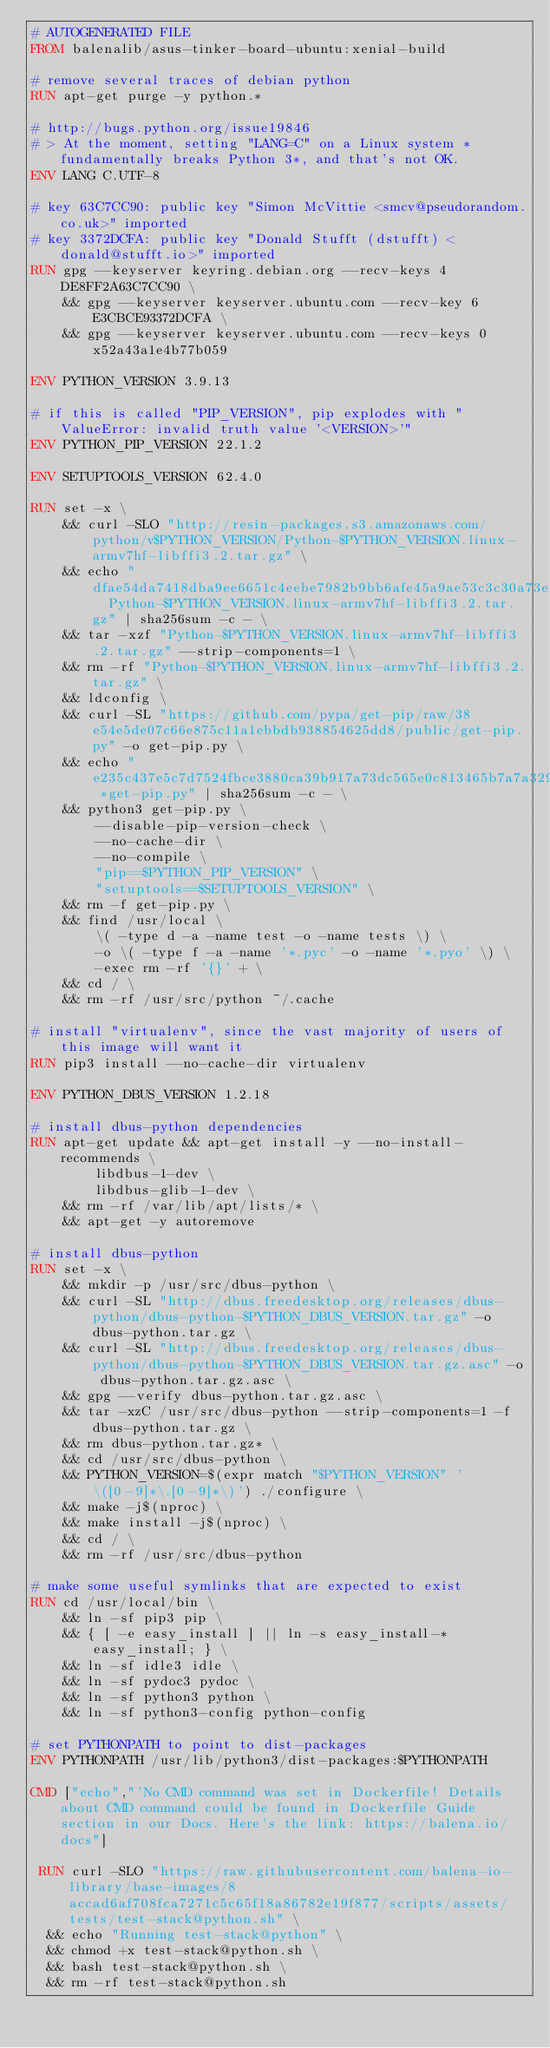Convert code to text. <code><loc_0><loc_0><loc_500><loc_500><_Dockerfile_># AUTOGENERATED FILE
FROM balenalib/asus-tinker-board-ubuntu:xenial-build

# remove several traces of debian python
RUN apt-get purge -y python.*

# http://bugs.python.org/issue19846
# > At the moment, setting "LANG=C" on a Linux system *fundamentally breaks Python 3*, and that's not OK.
ENV LANG C.UTF-8

# key 63C7CC90: public key "Simon McVittie <smcv@pseudorandom.co.uk>" imported
# key 3372DCFA: public key "Donald Stufft (dstufft) <donald@stufft.io>" imported
RUN gpg --keyserver keyring.debian.org --recv-keys 4DE8FF2A63C7CC90 \
	&& gpg --keyserver keyserver.ubuntu.com --recv-key 6E3CBCE93372DCFA \
	&& gpg --keyserver keyserver.ubuntu.com --recv-keys 0x52a43a1e4b77b059

ENV PYTHON_VERSION 3.9.13

# if this is called "PIP_VERSION", pip explodes with "ValueError: invalid truth value '<VERSION>'"
ENV PYTHON_PIP_VERSION 22.1.2

ENV SETUPTOOLS_VERSION 62.4.0

RUN set -x \
	&& curl -SLO "http://resin-packages.s3.amazonaws.com/python/v$PYTHON_VERSION/Python-$PYTHON_VERSION.linux-armv7hf-libffi3.2.tar.gz" \
	&& echo "dfae54da7418dba9ee6651c4eebe7982b9bb6afe45a9ae53c3c30a73ef91368a  Python-$PYTHON_VERSION.linux-armv7hf-libffi3.2.tar.gz" | sha256sum -c - \
	&& tar -xzf "Python-$PYTHON_VERSION.linux-armv7hf-libffi3.2.tar.gz" --strip-components=1 \
	&& rm -rf "Python-$PYTHON_VERSION.linux-armv7hf-libffi3.2.tar.gz" \
	&& ldconfig \
	&& curl -SL "https://github.com/pypa/get-pip/raw/38e54e5de07c66e875c11a1ebbdb938854625dd8/public/get-pip.py" -o get-pip.py \
    && echo "e235c437e5c7d7524fbce3880ca39b917a73dc565e0c813465b7a7a329bb279a *get-pip.py" | sha256sum -c - \
    && python3 get-pip.py \
        --disable-pip-version-check \
        --no-cache-dir \
        --no-compile \
        "pip==$PYTHON_PIP_VERSION" \
        "setuptools==$SETUPTOOLS_VERSION" \
	&& rm -f get-pip.py \
	&& find /usr/local \
		\( -type d -a -name test -o -name tests \) \
		-o \( -type f -a -name '*.pyc' -o -name '*.pyo' \) \
		-exec rm -rf '{}' + \
	&& cd / \
	&& rm -rf /usr/src/python ~/.cache

# install "virtualenv", since the vast majority of users of this image will want it
RUN pip3 install --no-cache-dir virtualenv

ENV PYTHON_DBUS_VERSION 1.2.18

# install dbus-python dependencies 
RUN apt-get update && apt-get install -y --no-install-recommends \
		libdbus-1-dev \
		libdbus-glib-1-dev \
	&& rm -rf /var/lib/apt/lists/* \
	&& apt-get -y autoremove

# install dbus-python
RUN set -x \
	&& mkdir -p /usr/src/dbus-python \
	&& curl -SL "http://dbus.freedesktop.org/releases/dbus-python/dbus-python-$PYTHON_DBUS_VERSION.tar.gz" -o dbus-python.tar.gz \
	&& curl -SL "http://dbus.freedesktop.org/releases/dbus-python/dbus-python-$PYTHON_DBUS_VERSION.tar.gz.asc" -o dbus-python.tar.gz.asc \
	&& gpg --verify dbus-python.tar.gz.asc \
	&& tar -xzC /usr/src/dbus-python --strip-components=1 -f dbus-python.tar.gz \
	&& rm dbus-python.tar.gz* \
	&& cd /usr/src/dbus-python \
	&& PYTHON_VERSION=$(expr match "$PYTHON_VERSION" '\([0-9]*\.[0-9]*\)') ./configure \
	&& make -j$(nproc) \
	&& make install -j$(nproc) \
	&& cd / \
	&& rm -rf /usr/src/dbus-python

# make some useful symlinks that are expected to exist
RUN cd /usr/local/bin \
	&& ln -sf pip3 pip \
	&& { [ -e easy_install ] || ln -s easy_install-* easy_install; } \
	&& ln -sf idle3 idle \
	&& ln -sf pydoc3 pydoc \
	&& ln -sf python3 python \
	&& ln -sf python3-config python-config

# set PYTHONPATH to point to dist-packages
ENV PYTHONPATH /usr/lib/python3/dist-packages:$PYTHONPATH

CMD ["echo","'No CMD command was set in Dockerfile! Details about CMD command could be found in Dockerfile Guide section in our Docs. Here's the link: https://balena.io/docs"]

 RUN curl -SLO "https://raw.githubusercontent.com/balena-io-library/base-images/8accad6af708fca7271c5c65f18a86782e19f877/scripts/assets/tests/test-stack@python.sh" \
  && echo "Running test-stack@python" \
  && chmod +x test-stack@python.sh \
  && bash test-stack@python.sh \
  && rm -rf test-stack@python.sh 
</code> 